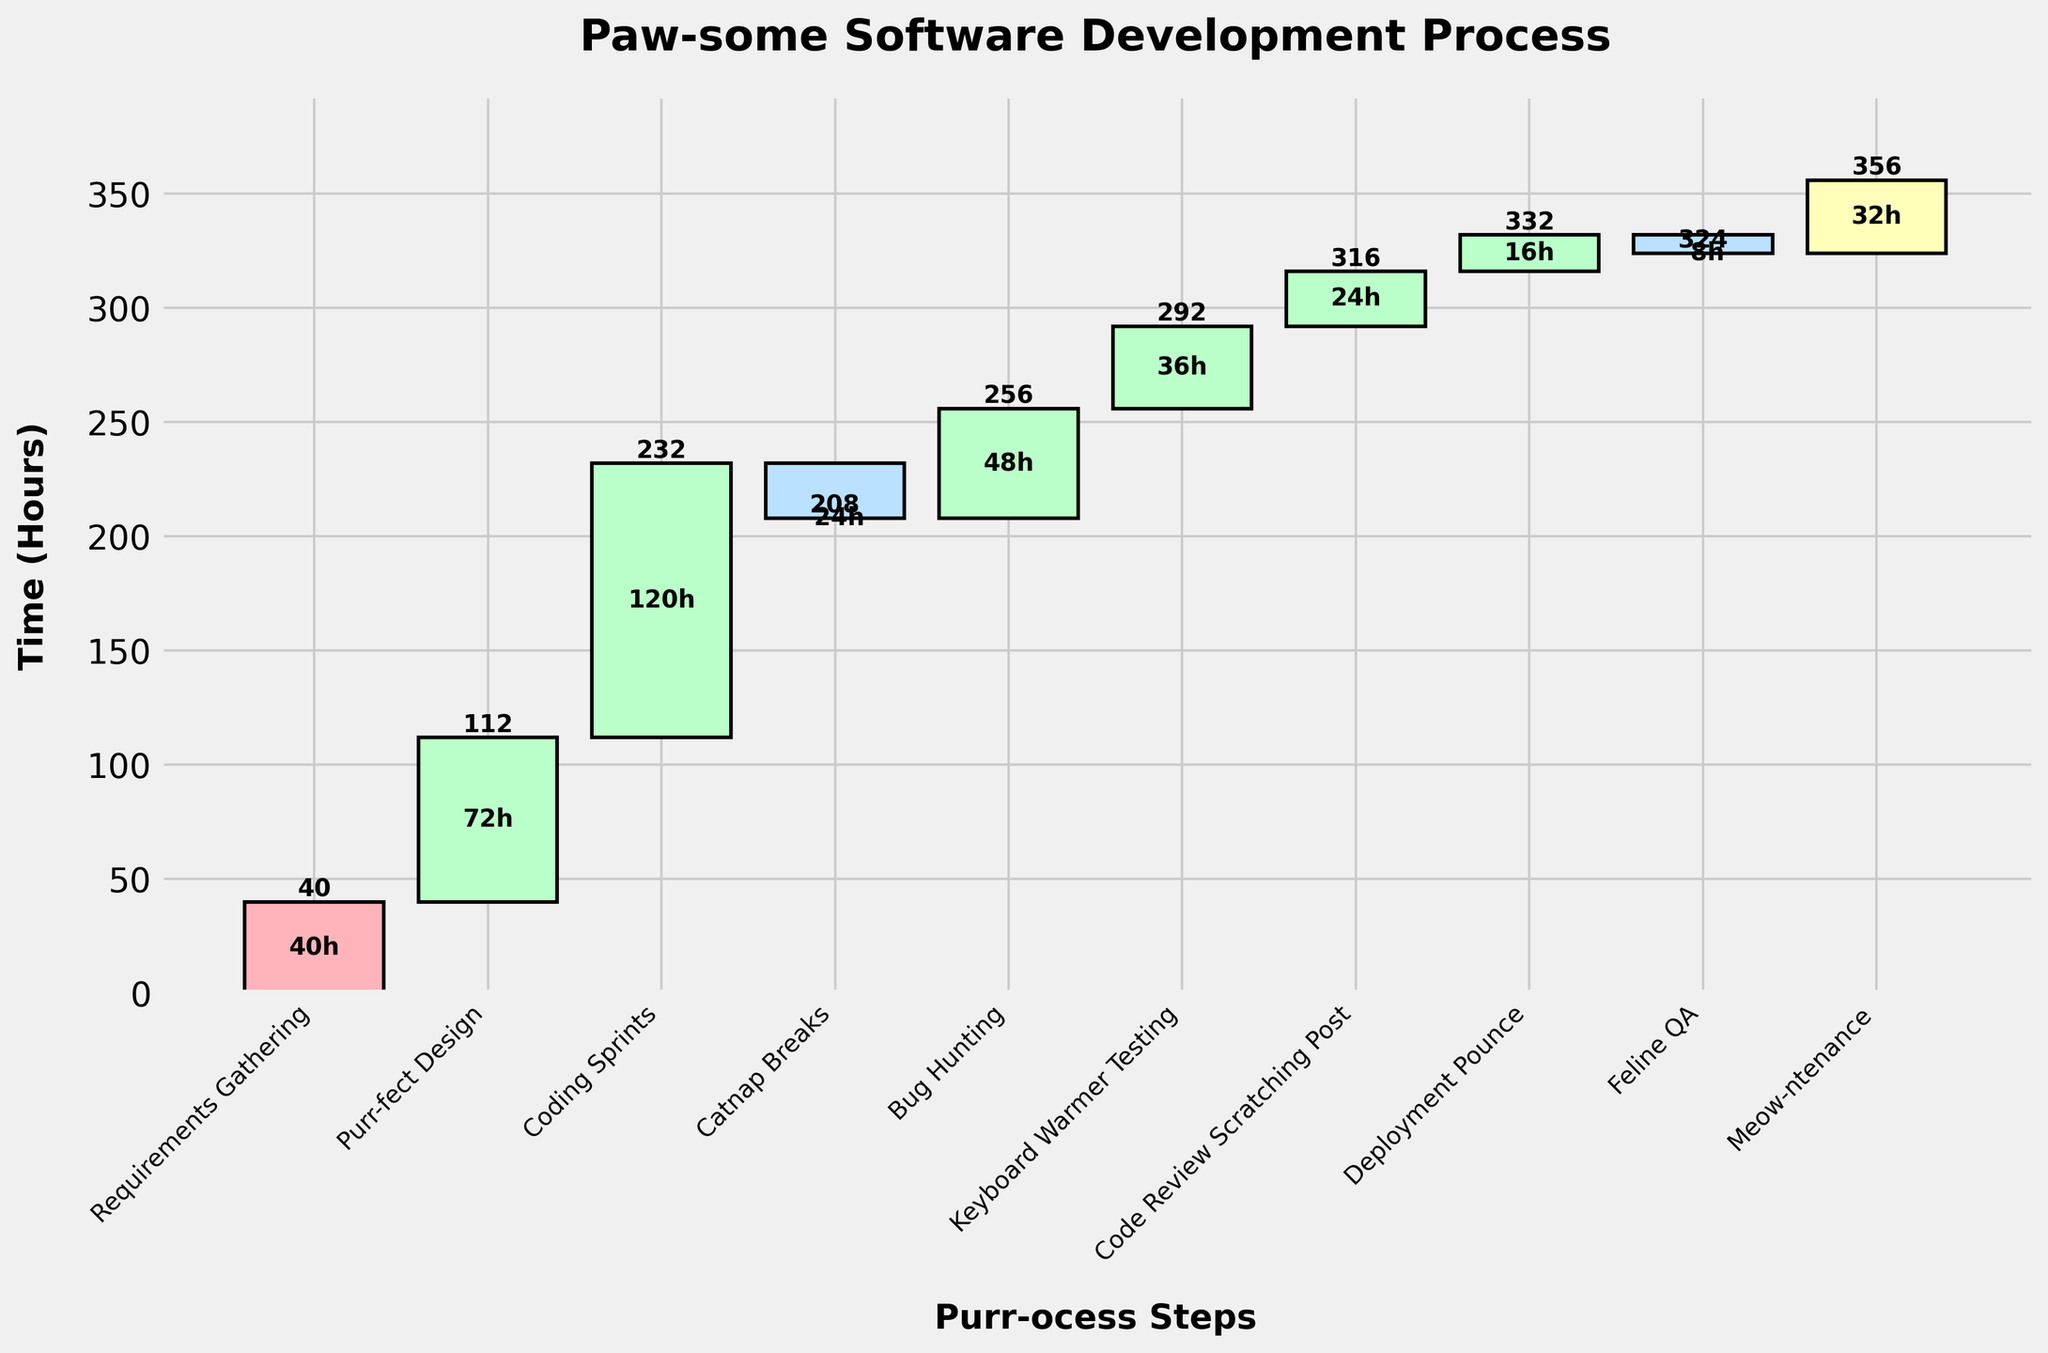What's the title of the figure? The title is usually located at the top of the figure. In this case, it reads "Paw-some Software Development Process".
Answer: Paw-some Software Development Process What color represents the "Negative" category? The colors for each category are visible in the bars. The "Negative" category has a light blue color.
Answer: Light blue What's the cumulative time after the "Coding Sprints" step? The cumulative time is shown above each bar. For "Coding Sprints," the cumulative time is 232 hours.
Answer: 232 hours Which step has the longest time allocation? By observing the height of the bars, the longest time allocation is associated with the step "Coding Sprints," which has 120 hours.
Answer: Coding Sprints How many hours are spent on "Meow-ntenance"? The time allocation for each step is written inside the respective bar. "Meow-ntenance" has 32 hours.
Answer: 32 hours What is the total time spent on all positive steps? Sum the time for all steps in the "Positive" category. This includes "Purr-fect Design" (72), "Coding Sprints" (120), "Bug Hunting" (48), "Keyboard Warmer Testing" (36), "Code Review Scratching Post" (24), and "Deployment Pounce" (16). The total is 72+120+48+36+24+16 = 316 hours.
Answer: 316 hours How much cumulative time is saved after all the negative steps are accounted for? Subtract the "Negative" steps ("Catnap Breaks" with -24 hours and "Feline QA" with -8 hours) from the cumulative time just before these steps. The time saved is -24 + -8 = -32 hours.
Answer: 32 hours How does the time spent on "Bug Hunting" compare to "Code Review Scratching Post"? Compare the time allocations for both steps. "Bug Hunting" has 48 hours, whereas "Code Review Scratching Post" has 24 hours. "Bug Hunting" has more time allocated.
Answer: Bug Hunting has more time What is the net gain of cumulative hours by the end of the process? The net gain is the cumulative time after the last step, "Meow-ntenance," which is 356 hours.
Answer: 356 hours Which step immediately follows "Keyboard Warmer Testing"? By looking at the order of the steps from left to right, the step right after "Keyboard Warmer Testing" is "Code Review Scratching Post."
Answer: Code Review Scratching Post 